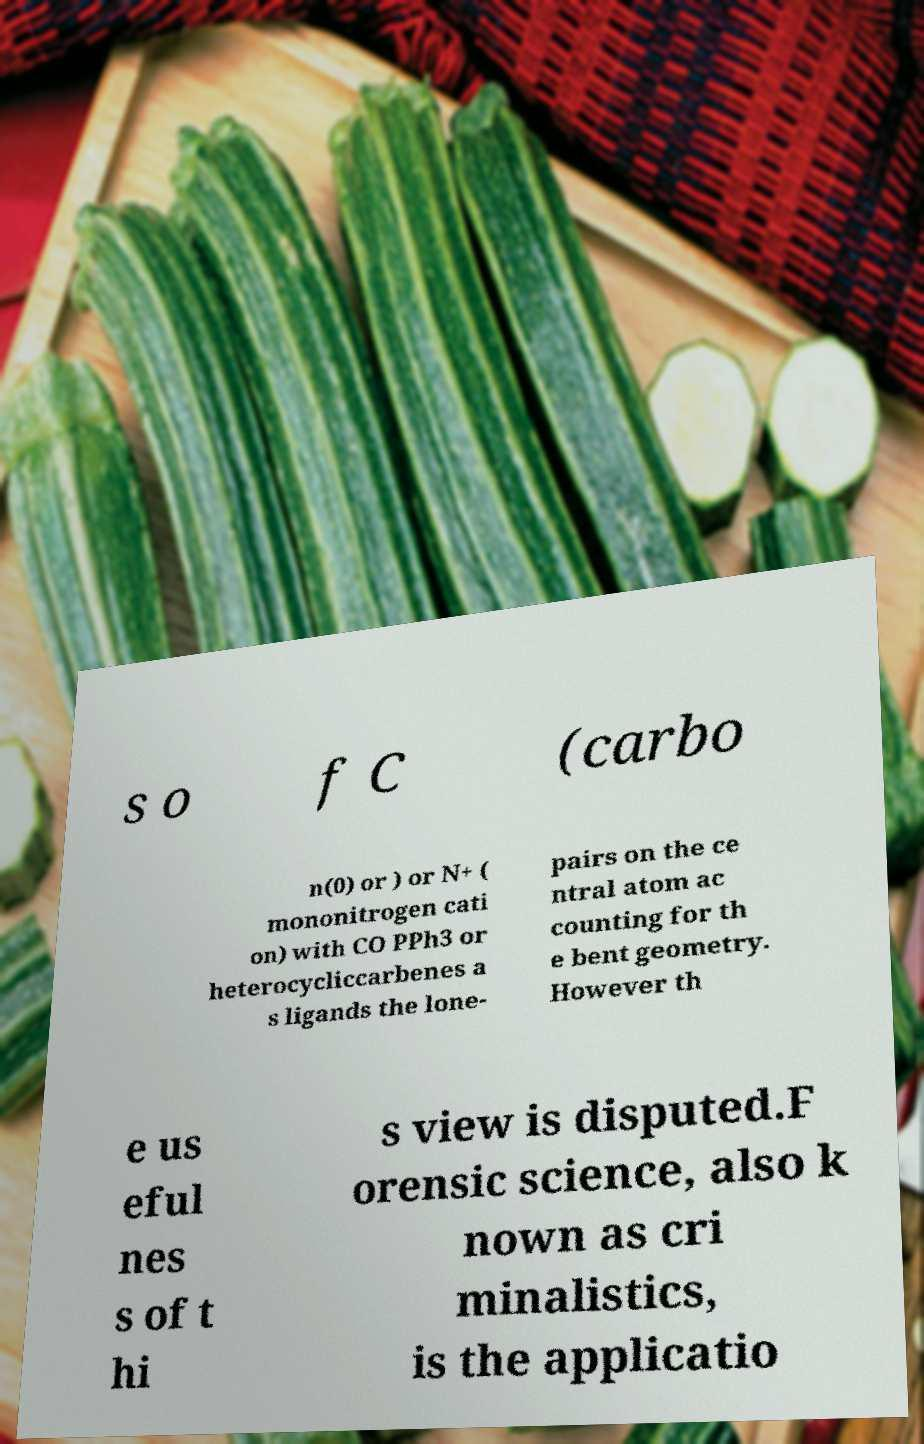What messages or text are displayed in this image? I need them in a readable, typed format. s o f C (carbo n(0) or ) or N+ ( mononitrogen cati on) with CO PPh3 or heterocycliccarbenes a s ligands the lone- pairs on the ce ntral atom ac counting for th e bent geometry. However th e us eful nes s of t hi s view is disputed.F orensic science, also k nown as cri minalistics, is the applicatio 